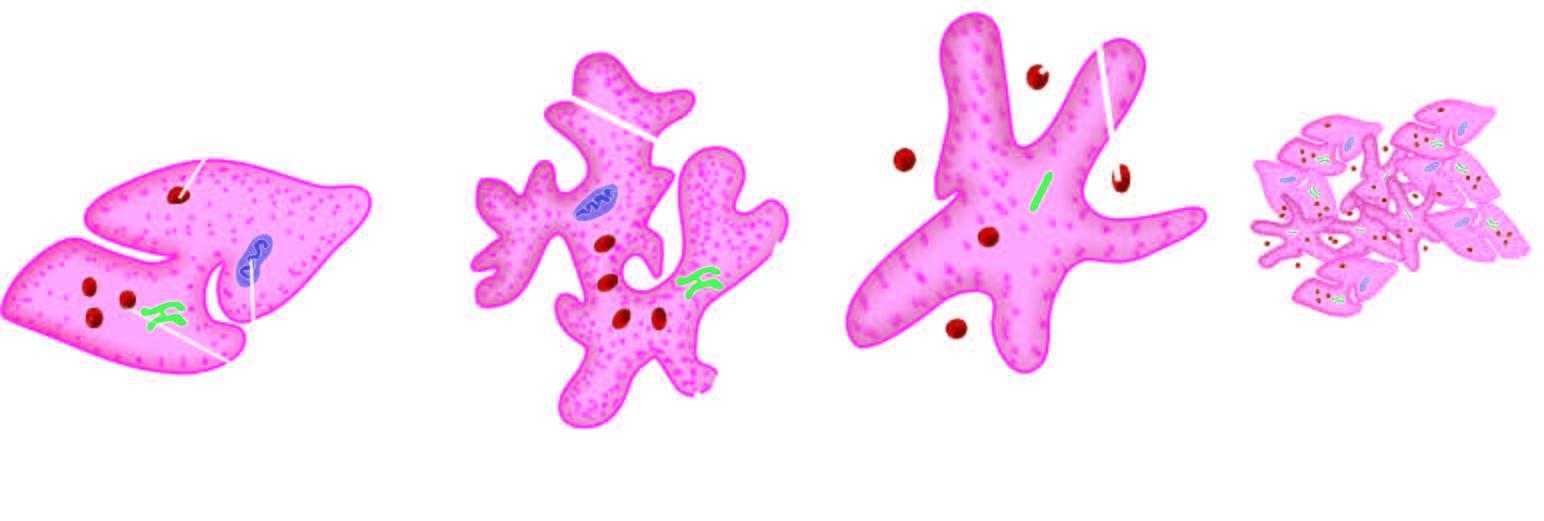does m phase form a tight plug?
Answer the question using a single word or phrase. No 